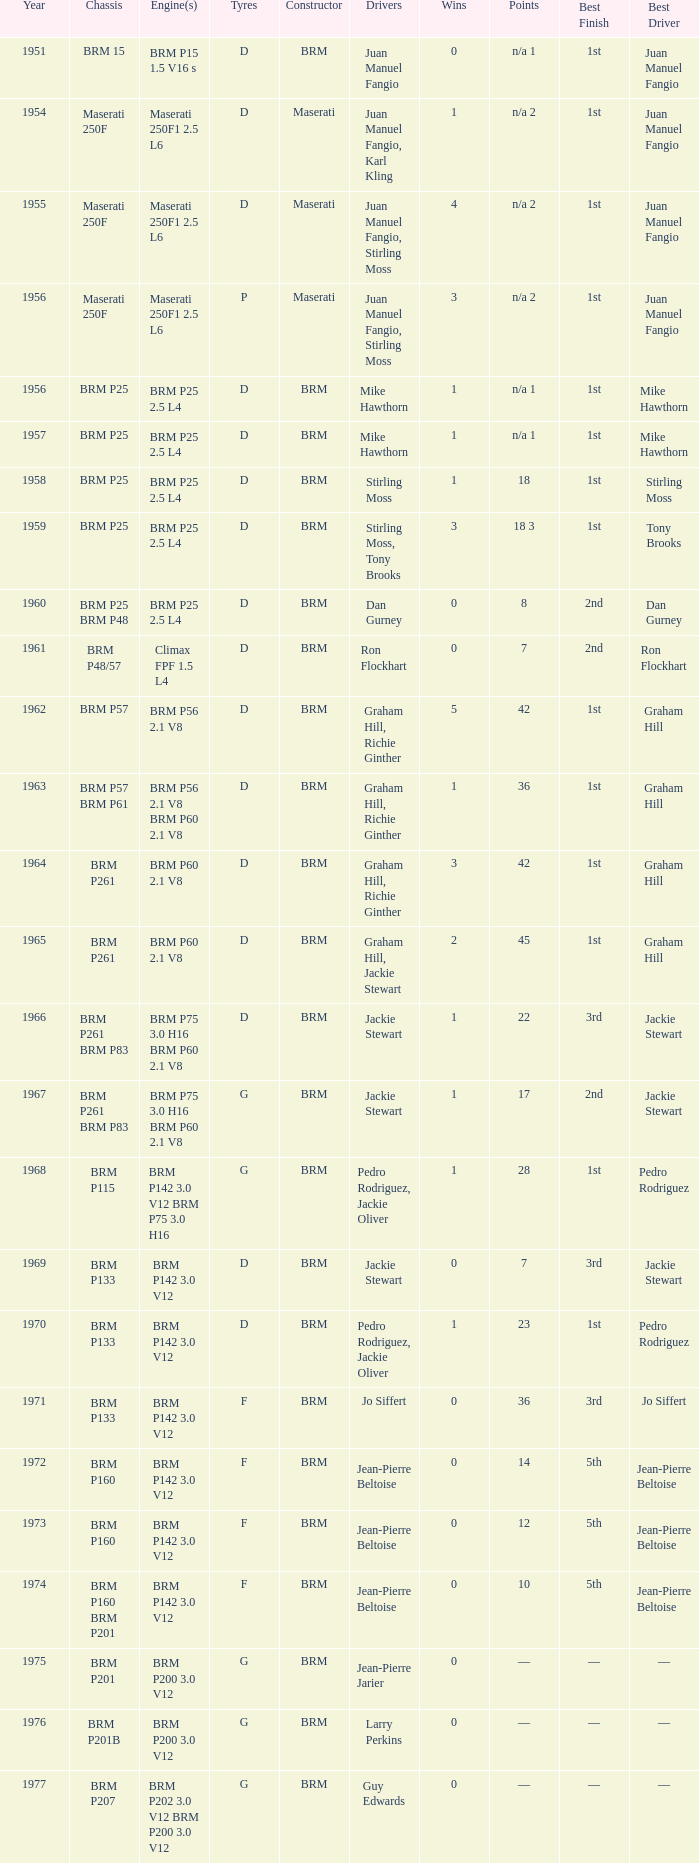Name the sum of year for engine of brm p202 3.0 v12 brm p200 3.0 v12 1977.0. 